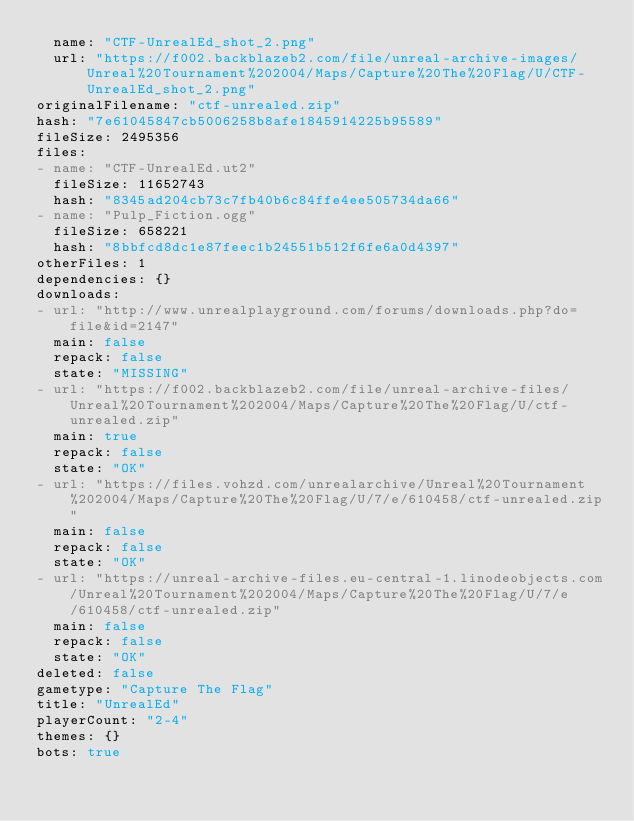<code> <loc_0><loc_0><loc_500><loc_500><_YAML_>  name: "CTF-UnrealEd_shot_2.png"
  url: "https://f002.backblazeb2.com/file/unreal-archive-images/Unreal%20Tournament%202004/Maps/Capture%20The%20Flag/U/CTF-UnrealEd_shot_2.png"
originalFilename: "ctf-unrealed.zip"
hash: "7e61045847cb5006258b8afe1845914225b95589"
fileSize: 2495356
files:
- name: "CTF-UnrealEd.ut2"
  fileSize: 11652743
  hash: "8345ad204cb73c7fb40b6c84ffe4ee505734da66"
- name: "Pulp_Fiction.ogg"
  fileSize: 658221
  hash: "8bbfcd8dc1e87feec1b24551b512f6fe6a0d4397"
otherFiles: 1
dependencies: {}
downloads:
- url: "http://www.unrealplayground.com/forums/downloads.php?do=file&id=2147"
  main: false
  repack: false
  state: "MISSING"
- url: "https://f002.backblazeb2.com/file/unreal-archive-files/Unreal%20Tournament%202004/Maps/Capture%20The%20Flag/U/ctf-unrealed.zip"
  main: true
  repack: false
  state: "OK"
- url: "https://files.vohzd.com/unrealarchive/Unreal%20Tournament%202004/Maps/Capture%20The%20Flag/U/7/e/610458/ctf-unrealed.zip"
  main: false
  repack: false
  state: "OK"
- url: "https://unreal-archive-files.eu-central-1.linodeobjects.com/Unreal%20Tournament%202004/Maps/Capture%20The%20Flag/U/7/e/610458/ctf-unrealed.zip"
  main: false
  repack: false
  state: "OK"
deleted: false
gametype: "Capture The Flag"
title: "UnrealEd"
playerCount: "2-4"
themes: {}
bots: true
</code> 